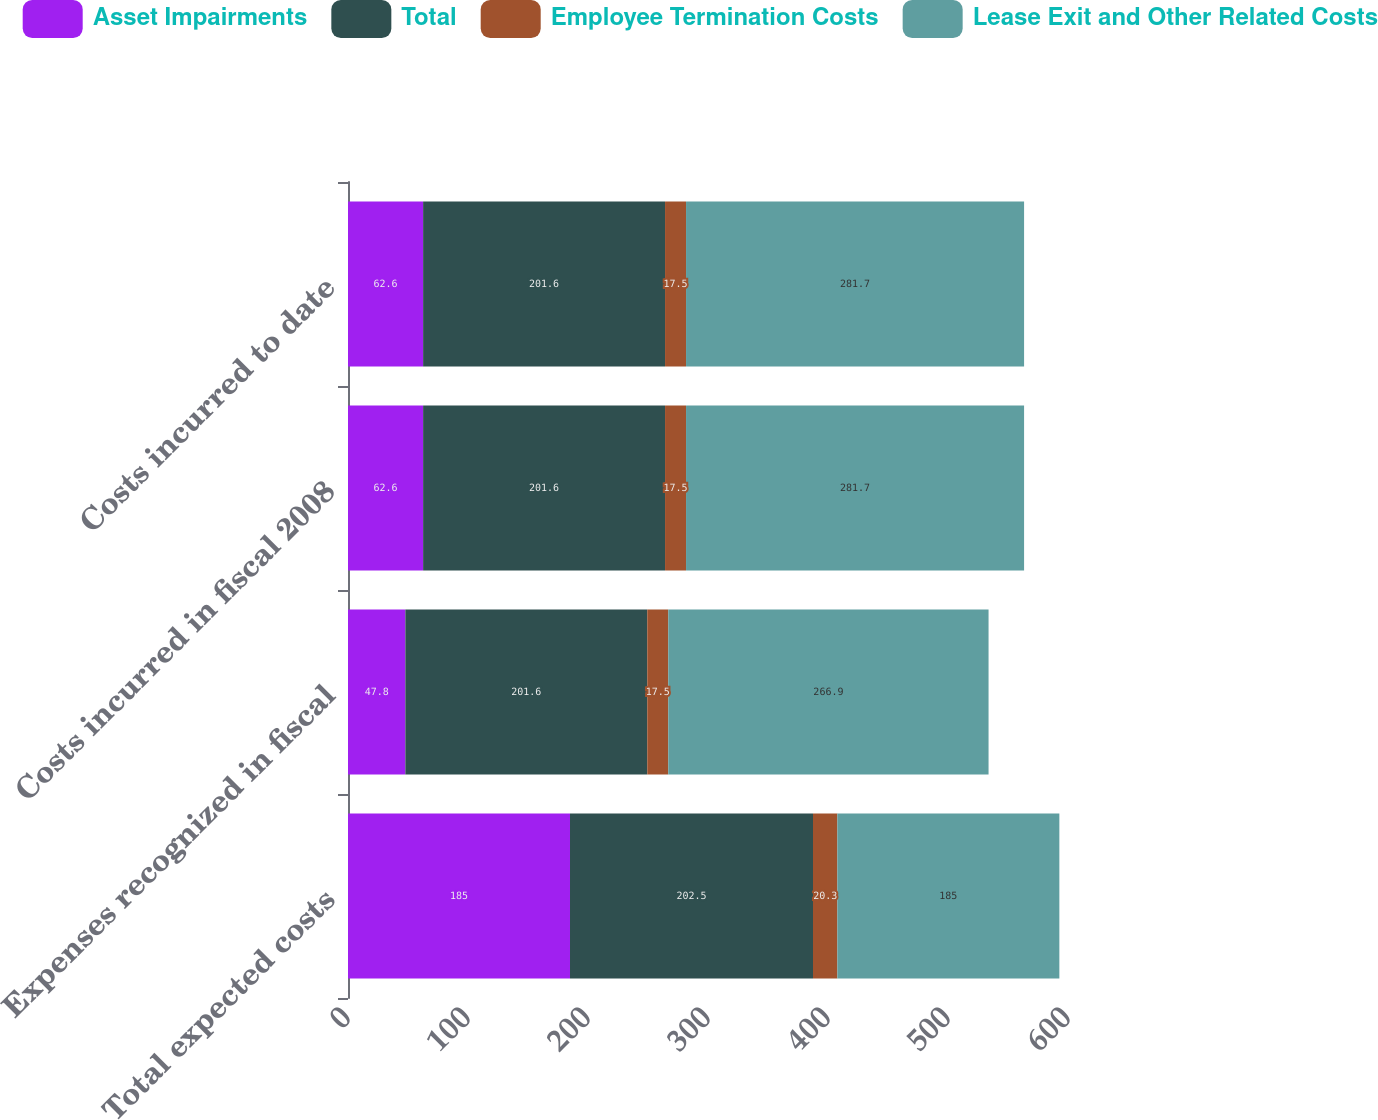<chart> <loc_0><loc_0><loc_500><loc_500><stacked_bar_chart><ecel><fcel>Total expected costs<fcel>Expenses recognized in fiscal<fcel>Costs incurred in fiscal 2008<fcel>Costs incurred to date<nl><fcel>Asset Impairments<fcel>185<fcel>47.8<fcel>62.6<fcel>62.6<nl><fcel>Total<fcel>202.5<fcel>201.6<fcel>201.6<fcel>201.6<nl><fcel>Employee Termination Costs<fcel>20.3<fcel>17.5<fcel>17.5<fcel>17.5<nl><fcel>Lease Exit and Other Related Costs<fcel>185<fcel>266.9<fcel>281.7<fcel>281.7<nl></chart> 